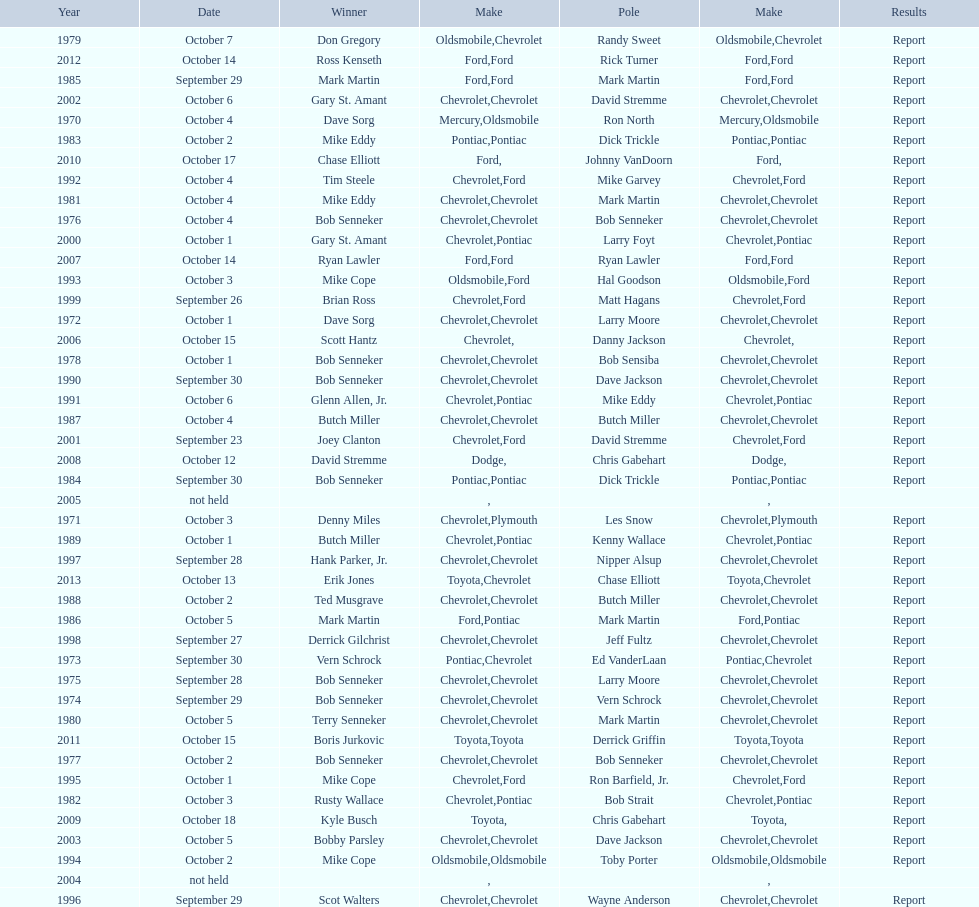How many winning oldsmobile vehicles made the list? 3. 